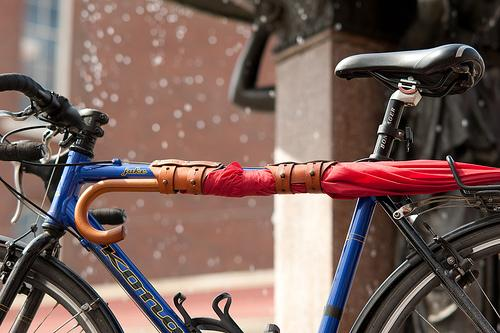Identify the texture of the wall behind the bike. The wall behind the bike has small specks on it, suggesting a rough texture. What are the colors of the seat and handlebars on the bike? The seat is black and the handlebars are black as well. Using a maximum of 15 words, summarize the main focus of the image. A blue bike with a red umbrella attached, parked outside a building in the rain. Mention an accessory present on the bike used to hold a beverage. There is a cupholder or water bottle holder on the bike. Count the number of black tires on the bike. There are two black tires on the bike. How would you describe the weather in the image? The weather in the image appears to be rainy, with rain falling down. What type of additional feature does the bike have for protection against rain? The bike has an umbrella attached to it for protection against rain. What is the primary color of the bicycle? The primary color of the bicycle is blue. What color is the umbrella attached to the bike? The umbrella attached to the bike is red. What is the function of the object located at X:171, Y:287, Width:85, and Height:85? It is a black water bottle holder on the bike. What is the umbrella protecting the bike rider from? The umbrella is protecting the rider from rain. Explain the sentiment portrayed by the image of a bicycle with a red umbrella attached to it. The sentiment portrayed is resourcefulness and preparedness for rain. What color are the specks on the wall at X:73, Y:32, Width:39, and Height:39? The specks are of various shades of black and gray. Can you see any windows on the building in the image? If so, provide their coordinates. Yes, there is a window on a building at X:19, Y:4, Width:46, Height:46. Identify the colors of these two elements: the handles at X:1, Y:93, Width:117, Height:117 and the lettering at X:101, Y:240, Width:67, Height:67. The handles are black, and the lettering is black. Evaluate the overall quality of the image with respect to clarity and brightness. The image has sufficient clarity and brightness for proper object identification. Identify the color of the bike's handlebars and give their location. The handlebars are black with coordinates X:9, Y:74, Width:95, Height:95. What are the colors of the following objects: the bike frame, the umbrella, and the seat? The bike frame is blue, the umbrella is red, and the seat is black. What can be inferred from the presence of raindrops in the image? It can be inferred that it is raining, or it has rained recently. Describe the object located at X:1, Y:42, Width:497, and Height:497. It is a blue bike sitting outside. Identify any unusual or unexpected elements in the image. An unexpected element is the umbrella attached to the bike. Describe any interaction happening between the bike and the umbrella in the image. The umbrella is attached to the bike to protect the rider from rain. Are any parts of the bicycle interacting with the wall behind it? No, the bike is not interacting directly with the wall behind it. What is the color of the bike at X:304 Y:239, Width:43, and Height:43? The bike is blue. What can you say about the object with the coordinates X:131, Y:164, Width:323, and Height:323? It is a red umbrella on the bike. Read any visible text or brand name on the bike and provide its coordinates. Black name on bike X:94, Y:238, Width:87, Height:87 What is unusual about the bicycle's front tire at X:45, Y:261, Width:72, and Height:72? There is nothing unusual about the front black tire on the bike. Describe the color and location of the umbrella in the image. The umbrella is red and located on the bike. 